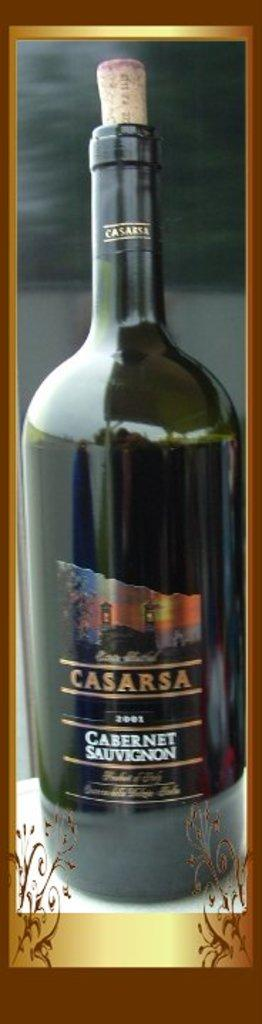<image>
Give a short and clear explanation of the subsequent image. A corked bottle of Casarsa Cabernet Sauvignon from 2001. 